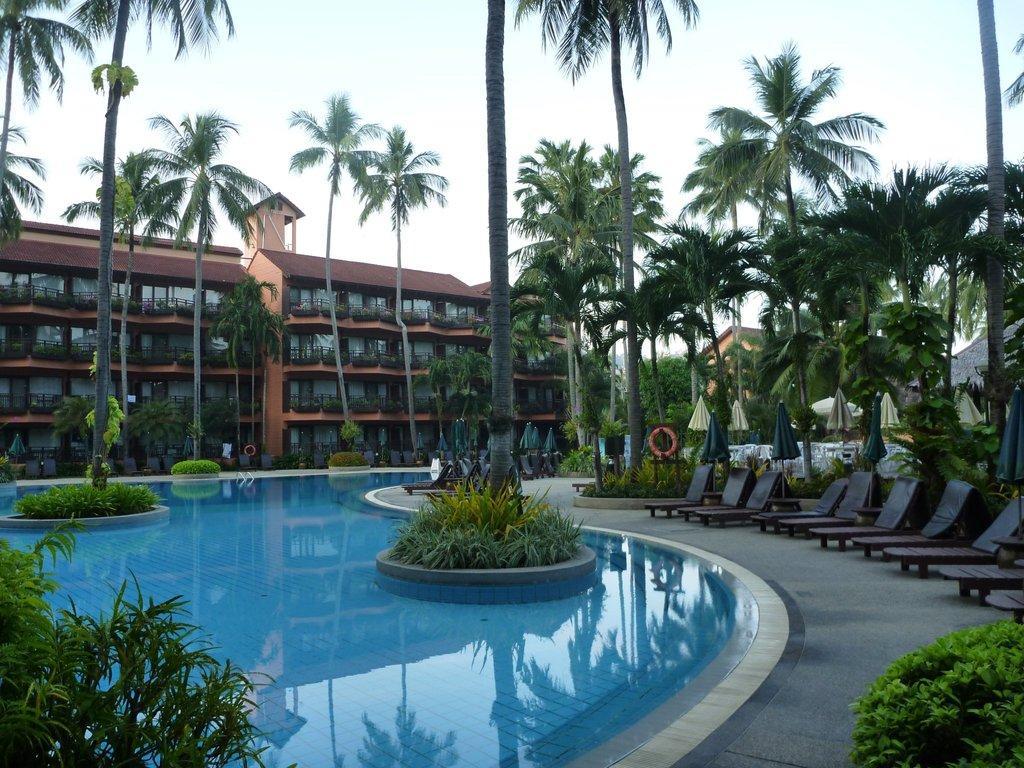In one or two sentences, can you explain what this image depicts? In this image I can see the ground, few plants which are green in color, the water, few trees, few chairs and few umbrellas. In the background I can see few buildings and the sky. 